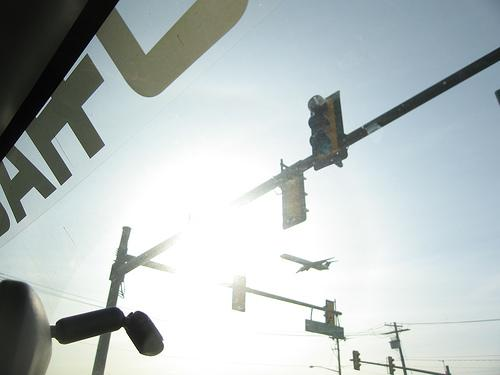Identify the activities or interactions of objects in the air. An airplane is flying, black power lines are stretched across the sky, and the sun is shining brightly. Provide a detailed caption for this image based on the provided image. An urban scene filled with various street signs and lights, a yellow traffic light, black power lines, an airplane flying in a clear blue sky, a bright sun, and some text on a glass surface. In a few words, describe the general sentiment or emotion that this image might evoke. Busy urban setting, brimming with activity and infrastructure. Analyze the object interaction between the airplane and the sky. The airplane is flying through the sky, interacting with the surrounding air to maintain altitude and direction. Inspect the way street signs are attached to poles in the image and describe the attachment method. Street signs are attached to poles using cords and metal support poles. Rate the image quality on a scale of 1 to 5, with 5 being the highest quality, based on the provided image. Based on the diversity of objects and their clear bounding boxes, the image quality can be rated as a 4.5 out of 5. List down all objects present in the image based on the image. green street signs on black poles, yellow traffic light on metal pole, black power lines in sky, airplane flying in sky, round white light in sky, white letters on glass surface, street signs attached to poles, street lights attached to poles, metal traffic street sign support pole, cords attaching street signs to metal poles, wing and tail of plane, a yellow stop light hanging, truck's logo, post of a stop light, clear blue sky, two rows of telephone wires, rear view mirror attached to a window, sun shining brightly, street sign hanging from a post, long wooden post, car ceiling, black board in sky, high light of sun, high intensity of sun, electric pole in air, text written in glass, opposite view of glass, opposite view of text, long electric wire, top of the pole, indicator on top, street lights on steel poles, street signs on chains, wires on a telephone pole, street lamps. Carry out a complex reasoning task to determine an overall theme of the image based on the provided image. Considering the presence of street signs, street lights, traffic lights, power lines, and other infrastructure elements, the overall theme of the image is urban development and transportation. Count the number of street lights and street signs visible in the image. There are 11 street lights and 12 street signs in the image. How many green street signs are mounted on black poles in the image? There are 10 green street signs on black poles. Describe the expression or intensity of the sun in the image. Sun shining brightly, high intensity of sun Describe the different types of street lights on the steel poles in the image. Street lights on steel poles of various heights and widths, street lamps with different shapes and sizes. Can you find a blue street sign on a white pole at X:312 Y:100 Width:170 Height:170? The instruction is misleading because the street sign is green and on a black pole, not blue and on a white pole. Can you identify any objects that are powered by electricity in the image? Street lights and black power lines in sky Can you see a square white light on the ground at X:118 Y:131 Width:221 Height:221? The instruction is misleading because the light is round and in the sky, not square and on the ground. Describe the location and orientation of the round white light in the sky. Round white light in sky is located at the X:118, Y:131 position and has width:221, height:221 Is there an airplane submerged in water at X:271 Y:240 Width:72 Height:72? The instruction is misleading because the airplane is flying in the sky, not submerged in water. Does the image show purple power lines on the ground at X:5 Y:269 Width:126 Height:126? The instruction is misleading because the power lines are black and in the sky, not purple and on the ground. Explain the orientation of the street signs and traffic lights in the image. Green street signs on black poles of varying sizes, yellow traffic light on metal pole, and street sign attached to pole with cords. Which of the following is not present in the image: (a) black power lines in sky, (b) green street sign on the black pole, (c) pink cat, (d) metal traffic street sign support pole? (c) Pink cat What color is the street sign on the black pole? Green What type of objects are connected through cords in the image? Street sign connecting to metal pole through cords Is there a red traffic light on a wooden pole at X:258 Y:81 Width:102 Height:102? The instruction is misleading because the traffic light is yellow and on a metal pole, not red and on a wooden pole. Detect the event happening in the sky. Airplane flying in sky Is there a pink street light on a plastic pole at X:305 Y:340 Width:41 Height:41? The instruction is misleading because the street light is attached to a metal pole, not a pink light on a plastic pole. Create a haiku about the objects found in the image. Signs and lights stand tall, Explain the structure of the connected objects in the image. Street sign attached to pole supported by a metal traffic street sign support pole and cords, street light attached to pole. Identify any text or letters present in the image. White letters on glass surface Create a short poem about the airplane in the sky. High above, in clear blue skies, Describe the materials and structures that support the objects in the image. Wooden post, metal traffic street sign support pole, steel pole, and chains or cords holding street signs and lights. Describe the sunlight's effect on the objects in the image. Sun shining brightly and illuminating the sky and objects in the image, casting shadows and highlights. What is the state of the traffic light in the image? Yellow stop light hanging What is written on the glass surface in the image? White letters Airplane, sun, and power lines are all parts of which scene?  Airplane flying in clear blue sky with sun shining brightly and black power lines in sky. Describe the objects hanging from the poles in the image. Green street signs, yellow traffic light, street lights, and cords attaching street sign to metal pole. 